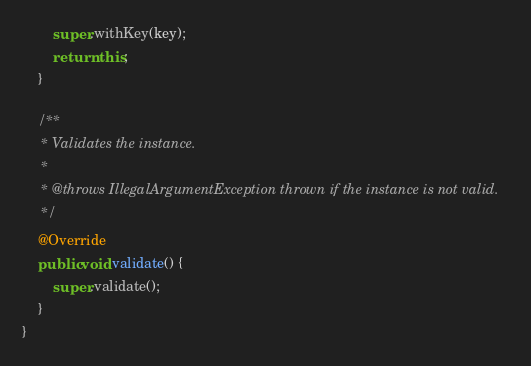Convert code to text. <code><loc_0><loc_0><loc_500><loc_500><_Java_>        super.withKey(key);
        return this;
    }

    /**
     * Validates the instance.
     *
     * @throws IllegalArgumentException thrown if the instance is not valid.
     */
    @Override
    public void validate() {
        super.validate();
    }
}
</code> 